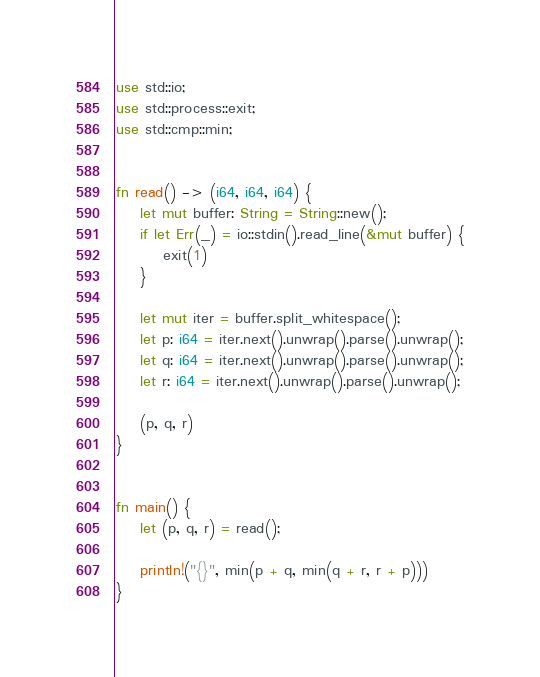<code> <loc_0><loc_0><loc_500><loc_500><_Rust_>use std::io;
use std::process::exit;
use std::cmp::min;


fn read() -> (i64, i64, i64) {
    let mut buffer: String = String::new();
    if let Err(_) = io::stdin().read_line(&mut buffer) {
        exit(1)
    }

    let mut iter = buffer.split_whitespace();
    let p: i64 = iter.next().unwrap().parse().unwrap();
    let q: i64 = iter.next().unwrap().parse().unwrap();
    let r: i64 = iter.next().unwrap().parse().unwrap();

    (p, q, r)
}


fn main() {
    let (p, q, r) = read();

    println!("{}", min(p + q, min(q + r, r + p)))
}</code> 